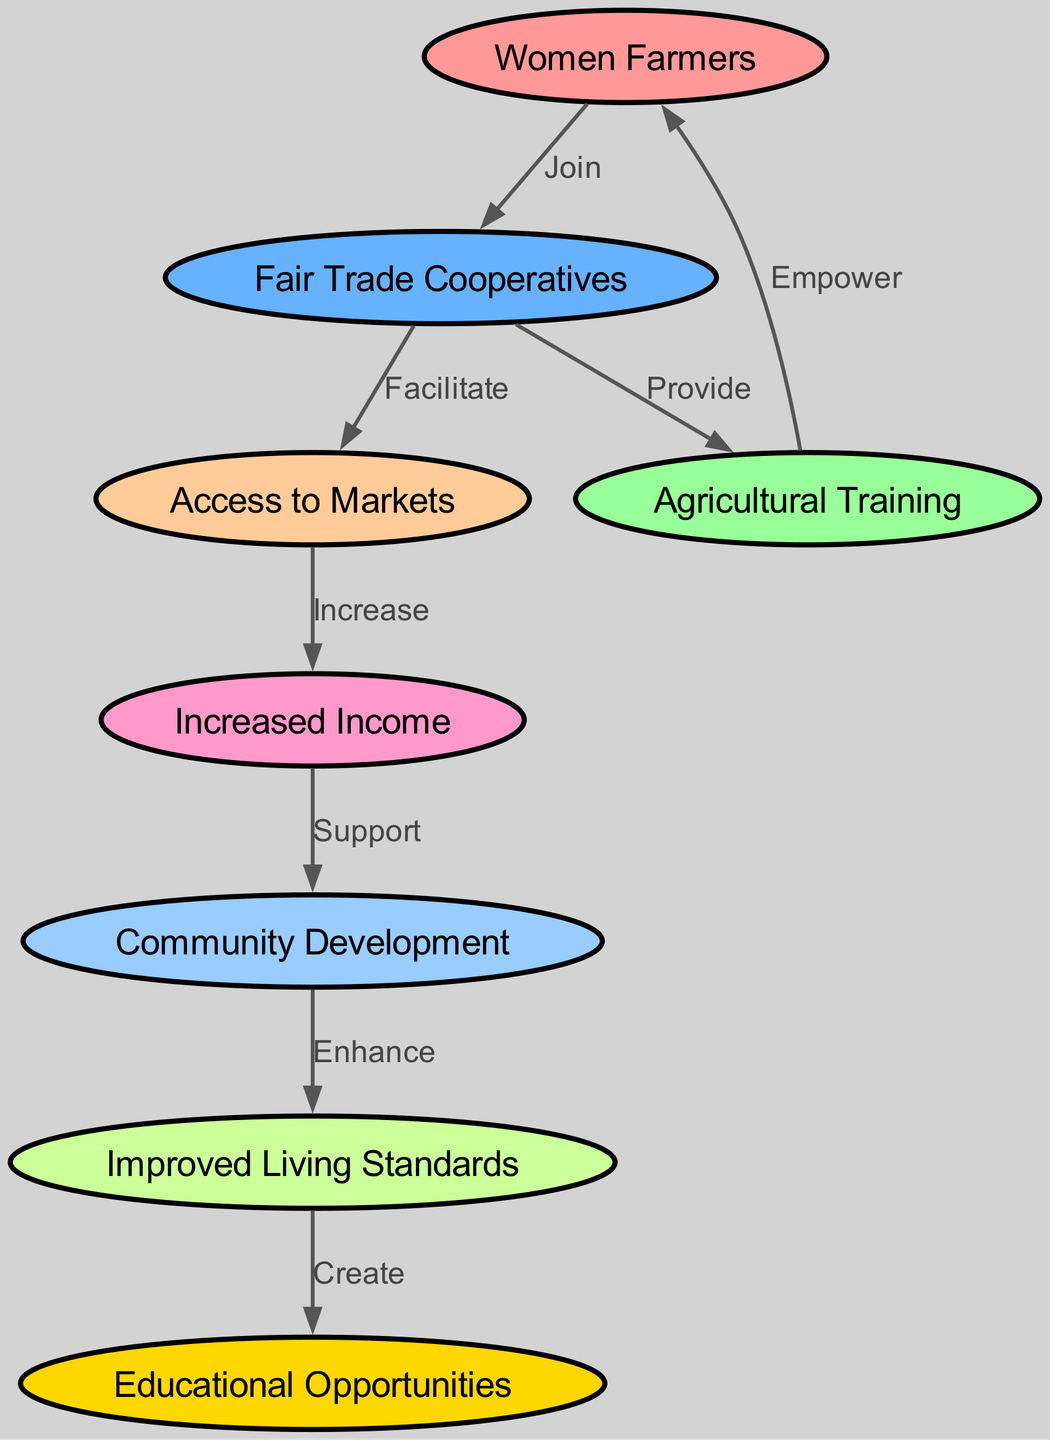What are the first two nodes in the diagram? The first two nodes in the diagram are listed in the order they appear. The first node is "Women Farmers" and the second node is "Fair Trade Cooperatives."
Answer: Women Farmers, Fair Trade Cooperatives How many nodes are there in total? The total number of nodes can be counted in the diagram, which lists eight distinct entities.
Answer: Eight What connection supports increased income for women farmers? The connection leading to increased income is the facilitation of access to markets that is enabled by fair trade cooperatives. The edge indicates that greater market access will result in increased income.
Answer: Access to Markets What is the outcome of the relationship between community development and improved living standards? The edge between "Community Development" and "Improved Living Standards" indicates that community development will enhance the living standards of the involved individuals.
Answer: Enhance How many edges are connecting the nodes in this diagram? The edges can be counted to ascertain the total number of connections or relationships within the diagram. There are a total of seven edges connecting the nodes.
Answer: Seven Which node is the last one in the flow of community improvement? The last node in the flow depicting community improvement is "Educational Opportunities," which is created as a result of improved living standards.
Answer: Educational Opportunities Describe the process from fair trade cooperatives to women farmers through agricultural training. The process starts with "Fair Trade Cooperatives" providing "Agricultural Training," which in turn empowers "Women Farmers." This shows a direct linkage from cooperatives, through training, to empowerment of farmers.
Answer: Empower What role do fair trade cooperatives play in accessing markets? Fair trade cooperatives have a facilitative role, allowing women farmers to gain better access to markets, thus creating pathways for their products and income opportunities.
Answer: Facilitate 